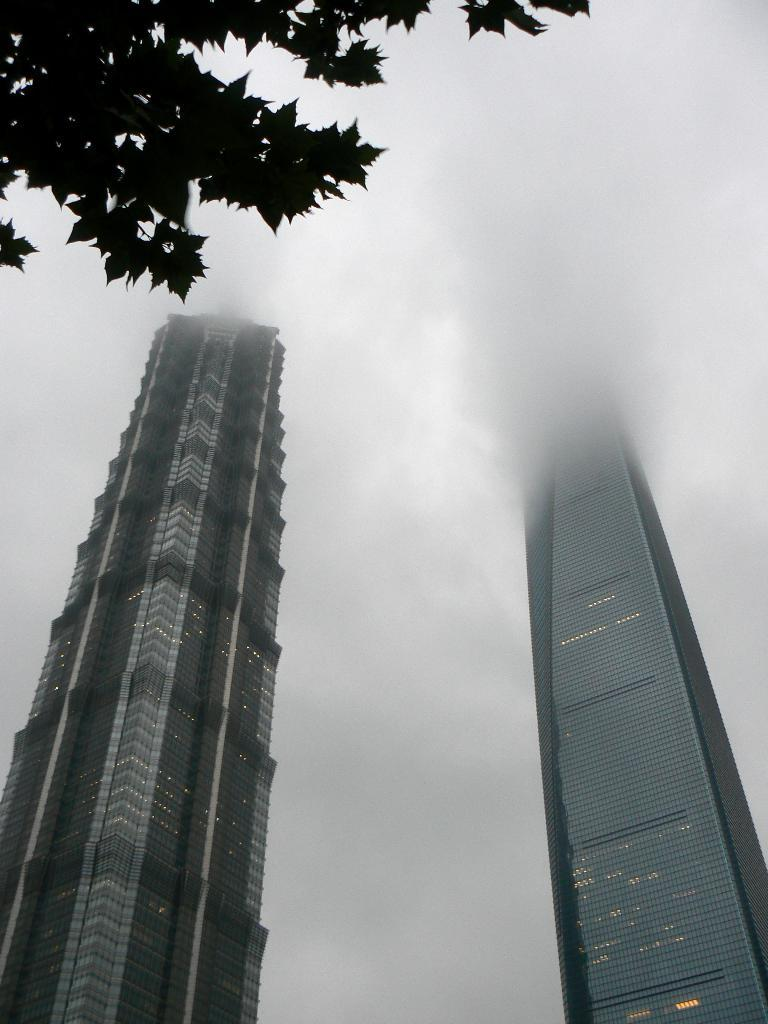What type of structures can be seen in the image? There are buildings in the image. What can be seen in the sky in the image? There are clouds in the sky in the image. Where are the branches of a tree located in the image? The branches of a tree are visible on the left side at the top of the image. What type of brush is being used to paint the event in the image? There is no brush or event depicted in the image; it features buildings, clouds, and tree branches. 